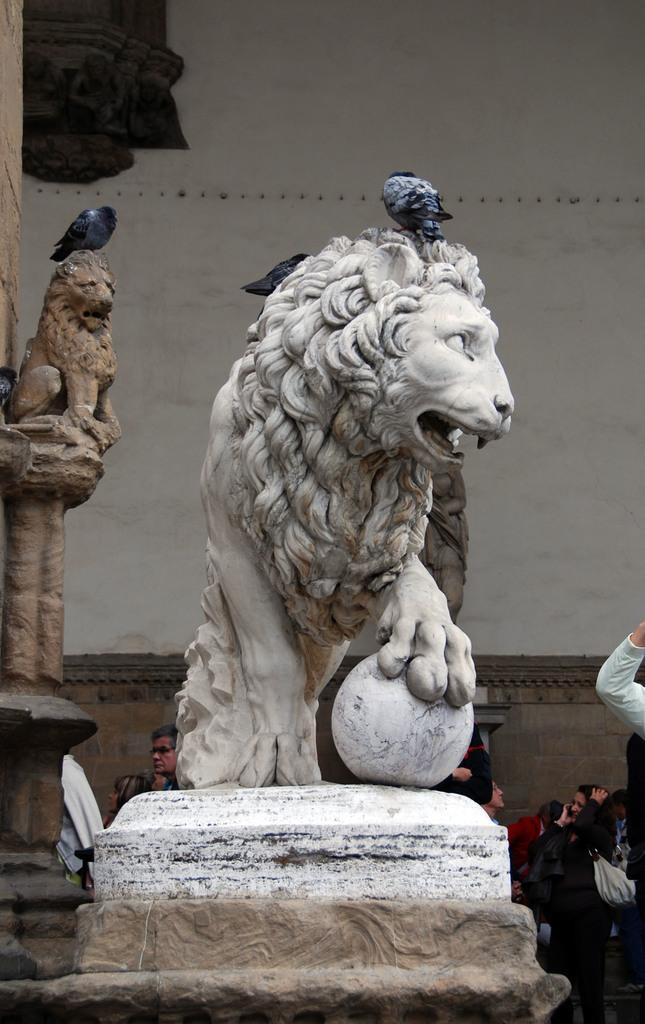In one or two sentences, can you explain what this image depicts? In this image I can see the statues of an animal. I can see few birds on the statues. In the background I can see the group of people and the black color object attached to the wall. 